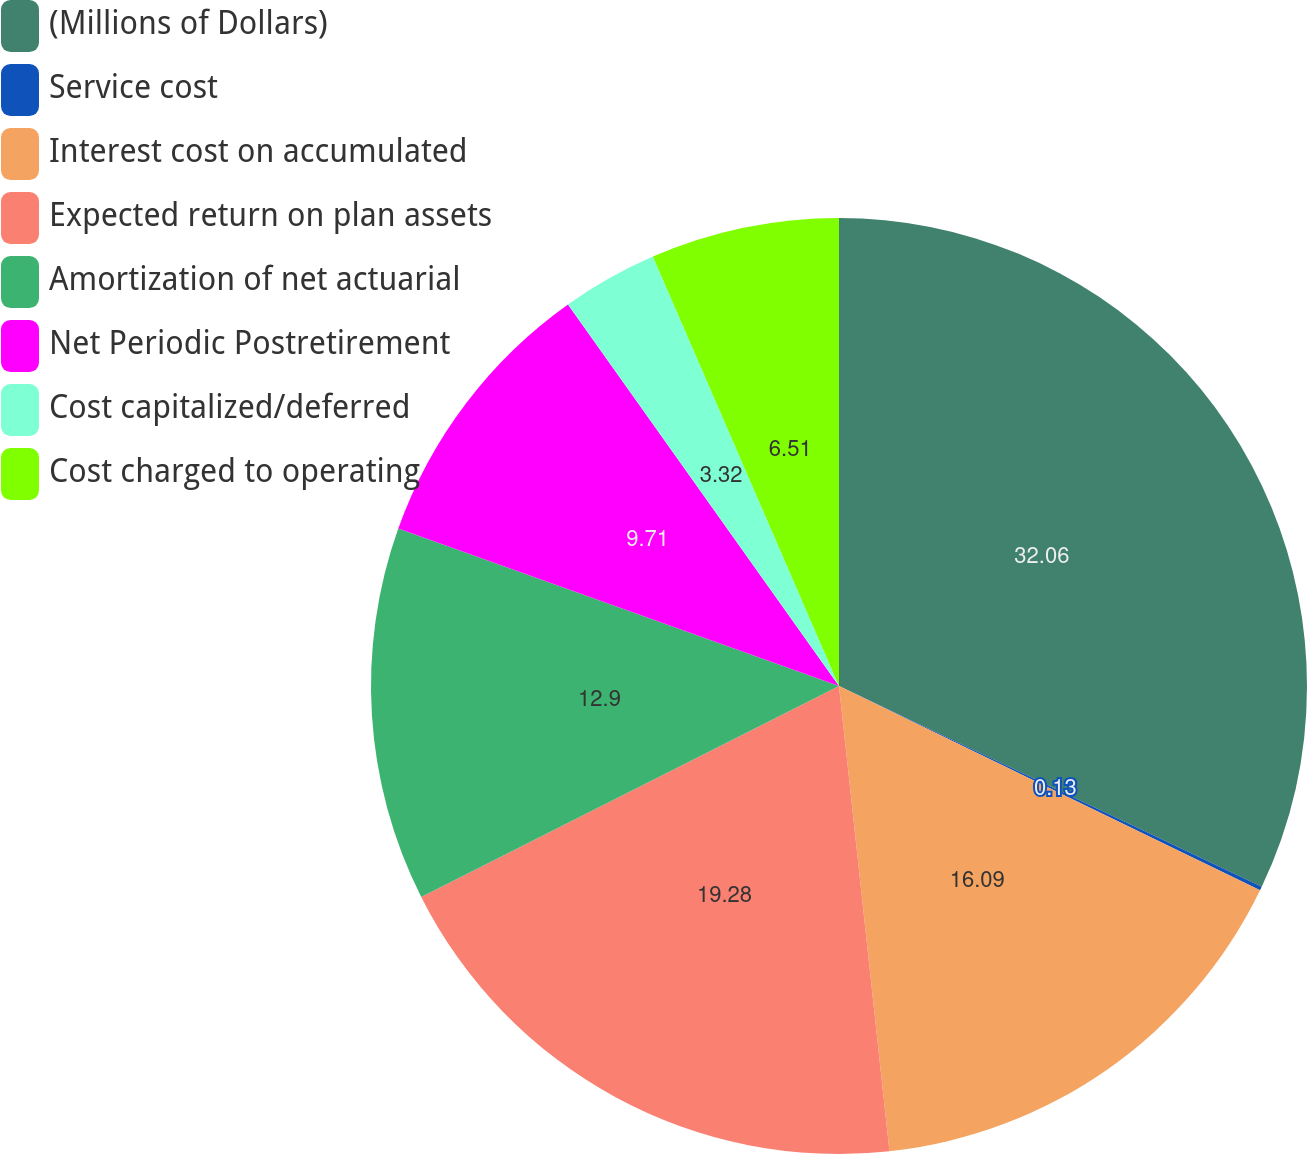Convert chart to OTSL. <chart><loc_0><loc_0><loc_500><loc_500><pie_chart><fcel>(Millions of Dollars)<fcel>Service cost<fcel>Interest cost on accumulated<fcel>Expected return on plan assets<fcel>Amortization of net actuarial<fcel>Net Periodic Postretirement<fcel>Cost capitalized/deferred<fcel>Cost charged to operating<nl><fcel>32.06%<fcel>0.13%<fcel>16.09%<fcel>19.28%<fcel>12.9%<fcel>9.71%<fcel>3.32%<fcel>6.51%<nl></chart> 